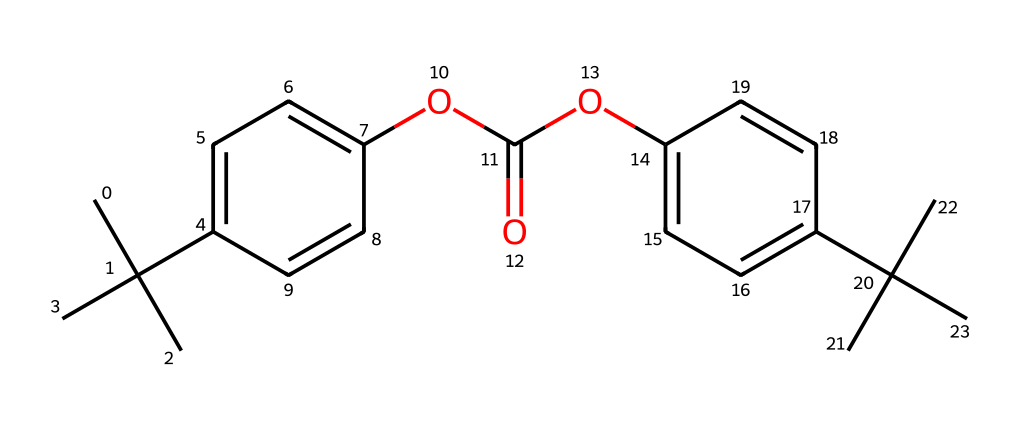How many carbon atoms are in this chemical structure? The SMILES representation contains multiple groups of carbon atoms represented by 'C'. By counting all the distinct 'C' occurrences in the structure, we identify that there are a total of 24 carbon atoms.
Answer: 24 What is the functional group present in this chemical? Observing the SMILES structure, we can identify the presence of an ester functional group, which is characterized by the 'OC(=O)' sequence in the SMILES. This indicates that the compound contains an ester linkage.
Answer: ester Can this polycarbonate be described as rigid or flexible? Based on the presence of aromatic rings (indicated by 'c1ccc' structures along with aliphatic groups), the polycarbonate would typically exhibit rigidity due to its stiff backbone and intermolecular forces involved in the structure.
Answer: rigid What type of polymer is represented by this chemical structure? Polycarbonate is a type of thermoplastic polymer. This specific SMILES indicates that it is composed of repeating carbonate groups and possesses properties typical to polycarbonates in terms of durability and clarity.
Answer: thermoplastic How many oxygen atoms are in this chemical? The SMILES shows two instances of 'O' that correspond to the ester functional group. Therefore, by counting these instances, we can conclude that there are four oxygen atoms in total present in the chemical structure.
Answer: 4 What kind of modifications can be made to improve its impact resistance? The presence of bulky aliphatic substituents suggests the potential for modifying the backbone by adding more branches or functional groups to enhance its impact resistance. This is commonly done in polymers to improve toughness.
Answer: branching 